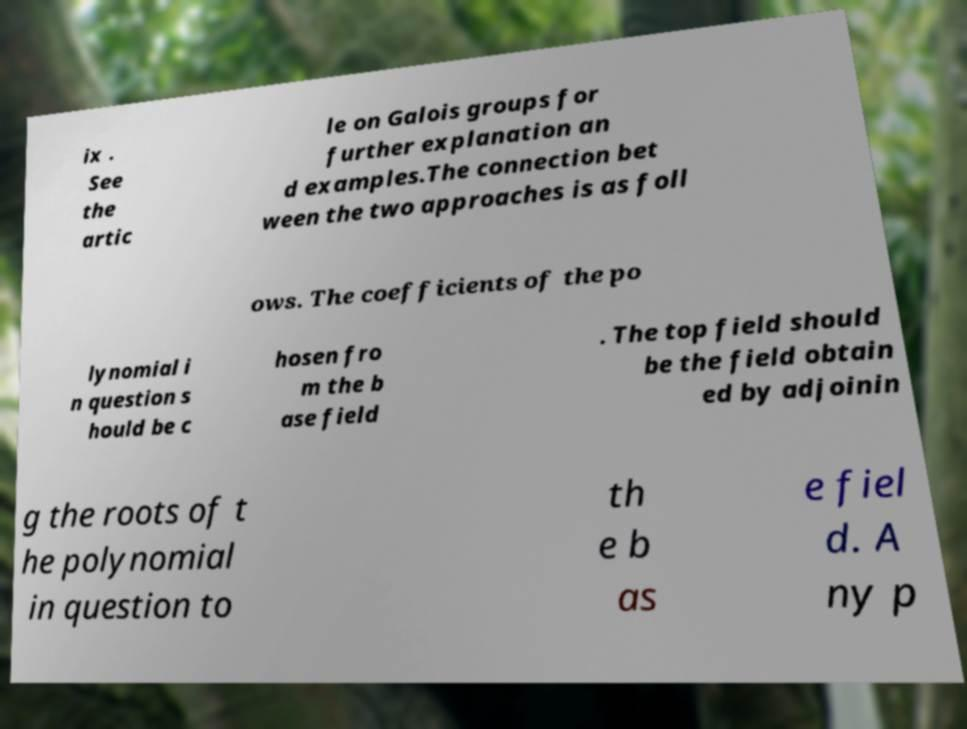There's text embedded in this image that I need extracted. Can you transcribe it verbatim? ix . See the artic le on Galois groups for further explanation an d examples.The connection bet ween the two approaches is as foll ows. The coefficients of the po lynomial i n question s hould be c hosen fro m the b ase field . The top field should be the field obtain ed by adjoinin g the roots of t he polynomial in question to th e b as e fiel d. A ny p 